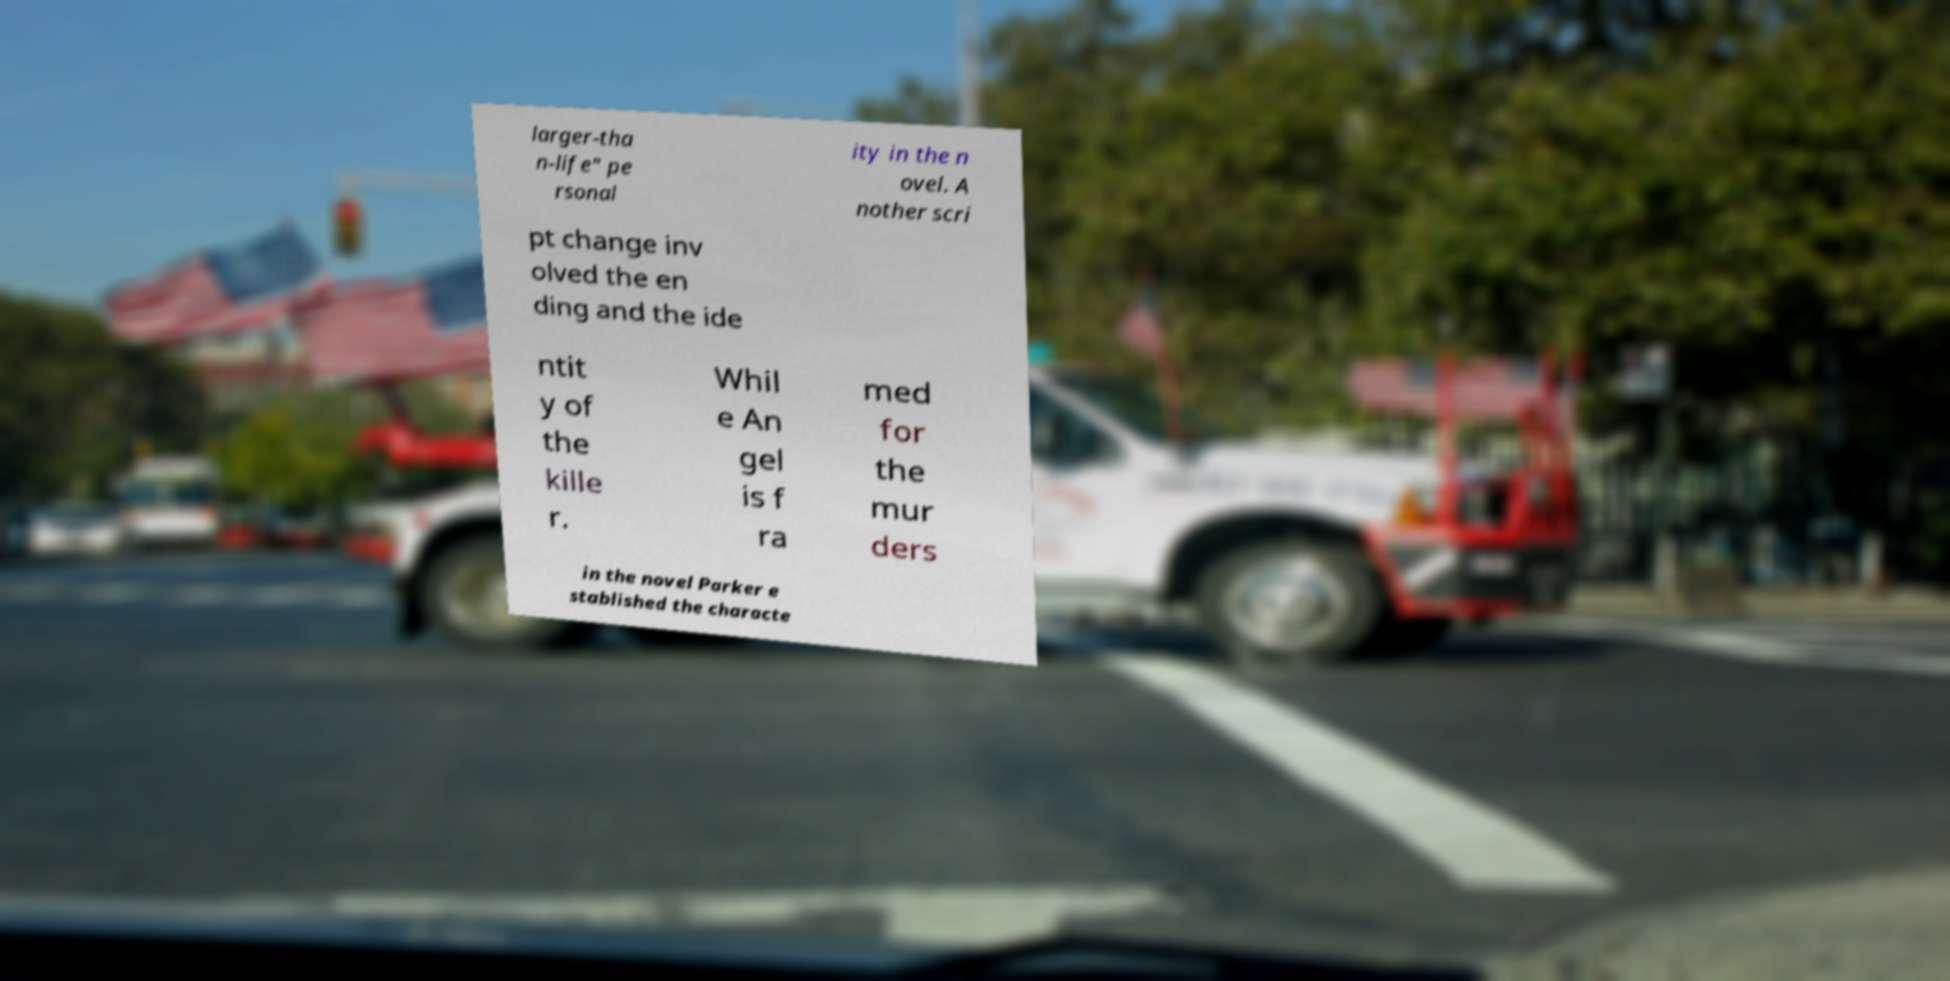There's text embedded in this image that I need extracted. Can you transcribe it verbatim? larger-tha n-life" pe rsonal ity in the n ovel. A nother scri pt change inv olved the en ding and the ide ntit y of the kille r. Whil e An gel is f ra med for the mur ders in the novel Parker e stablished the characte 